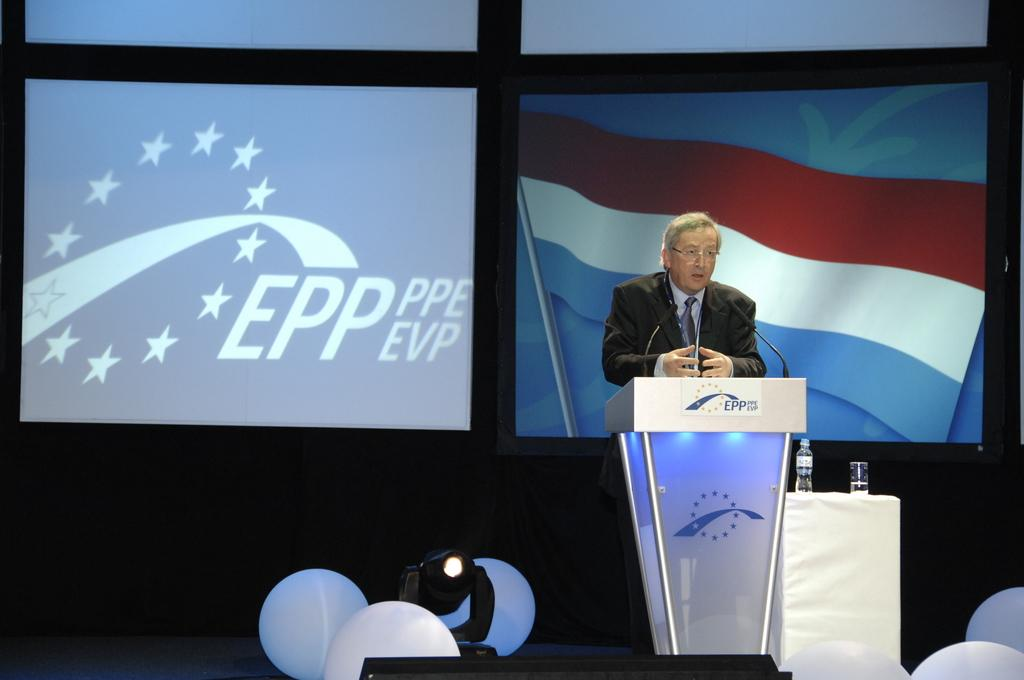What is the man in the image doing? The man is speaking in the image. What is the man using to amplify his voice? There is a microphone in the image that the man is likely using. What can be seen illuminated in the image? There is a light in the image that provides illumination. What decorative items are present in the image? There are balloons and a flag in the image. What objects are present for hydration in the image? There is a glass and a water bottle in the image. What type of earthquake can be seen shaking the building in the image? There is no earthquake or building present in the image; it features a man speaking with a microphone, light, balloons, flag, glass, and water bottle. What actor is performing in the image? There is no actor or performance present in the image; it features a man speaking with a microphone, light, balloons, flag, glass, and water bottle. 